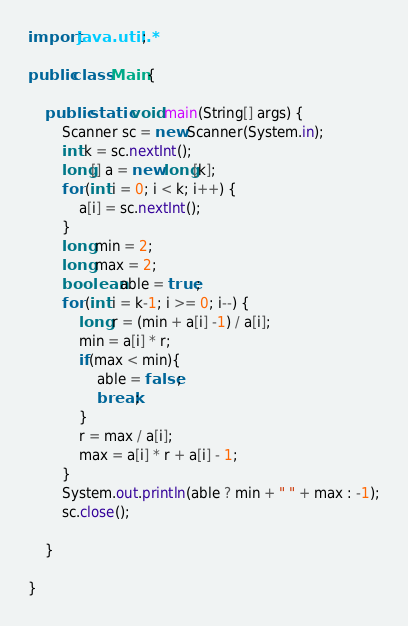Convert code to text. <code><loc_0><loc_0><loc_500><loc_500><_Java_>import java.util.*;

public class Main {

    public static void main(String[] args) {
        Scanner sc = new Scanner(System.in);
        int k = sc.nextInt();
        long[] a = new long[k];
        for (int i = 0; i < k; i++) {
            a[i] = sc.nextInt();
        }
        long min = 2;
        long max = 2;
        boolean able = true;
        for (int i = k-1; i >= 0; i--) {
            long r = (min + a[i] -1) / a[i];
            min = a[i] * r;
            if(max < min){
                able = false;
                break;
            }
            r = max / a[i];
            max = a[i] * r + a[i] - 1;
        }
        System.out.println(able ? min + " " + max : -1);
        sc.close();

    }

}
</code> 